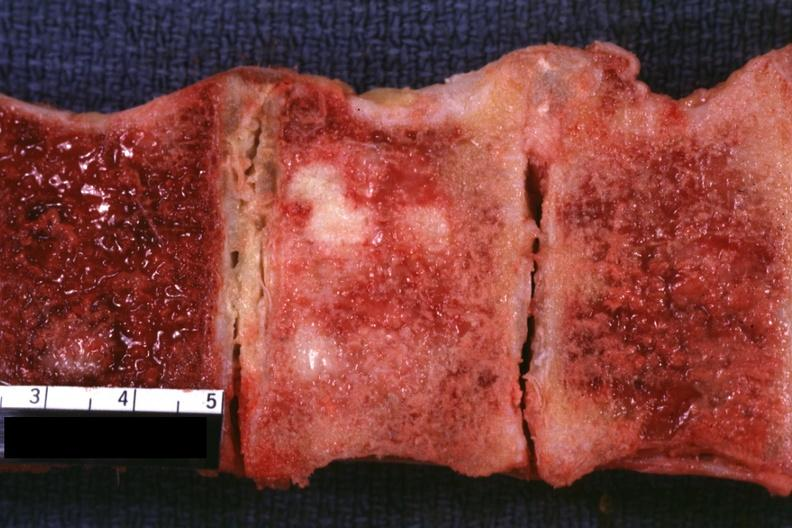what does this image show?
Answer the question using a single word or phrase. Sectioned vertebral bodies with obvious tumor 